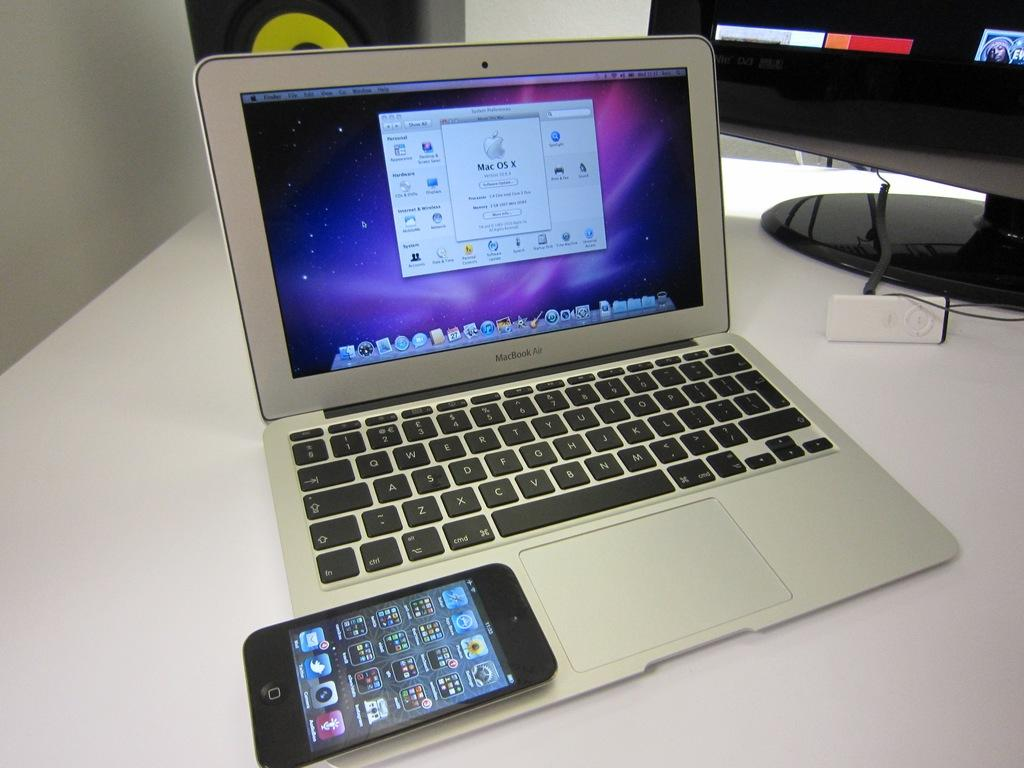<image>
Present a compact description of the photo's key features. An open MacBook Air has a cell phone resting on it. 